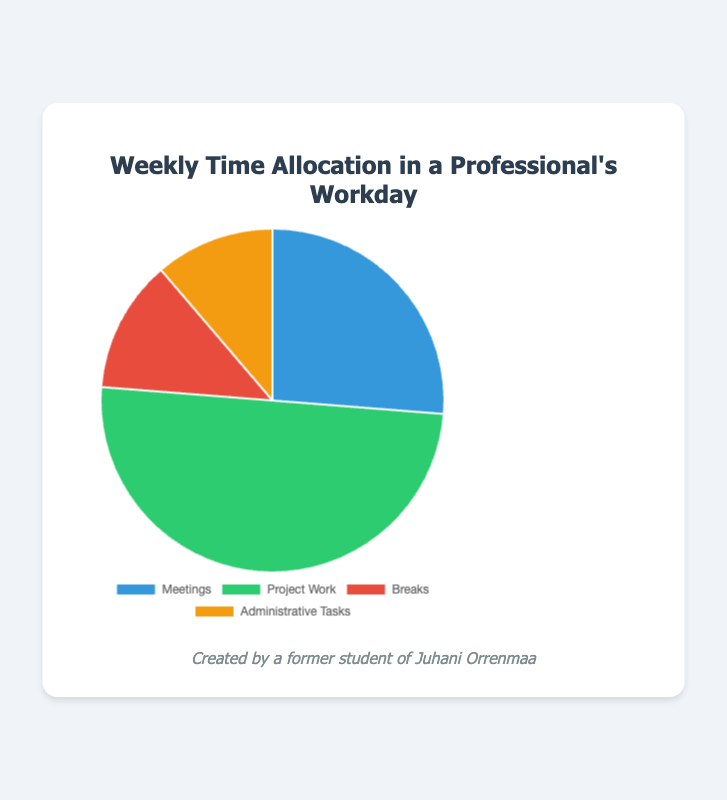What is the most time-consuming activity in a professional's workday? The figure shows the time allocation for various activities. Project Work takes up 20.0 hours, which is the highest among the activities listed.
Answer: Project Work What percentage of the total time is spent on Meetings? To find the percentage, sum up all the time allocations and then divide the time for Meetings by this total. The total time is 10.5 + 20.0 + 5.0 + 4.5 = 40.0 hours. The percentage for Meetings is (10.5 / 40.0) * 100 = 26.25%.
Answer: 26.25% How much more time is spent on Project Work compared to Breaks? Subtract the time spent on Breaks from the time spent on Project Work: 20.0 - 5.0 = 15.0 hours.
Answer: 15.0 hours What is the combined time spent on Breaks and Administrative Tasks? Sum the time for Breaks and Administrative Tasks: 5.0 + 4.5 = 9.5 hours.
Answer: 9.5 hours If the time for Meetings were increased by 50%, how much total time would that consume? Increase the time for Meetings by 50%: 10.5 * 1.5 = 15.75 hours.
Answer: 15.75 hours Which activity has the least amount of time allocated, and what is this amount? The figure shows the time allocation for each activity. Administrative Tasks have the least amount of time, which is 4.5 hours.
Answer: Administrative Tasks, 4.5 hours What fraction of the time is spent on Breaks compared to the total time? The total time is 40.0 hours, and the time spent on Breaks is 5.0 hours. The fraction is 5.0 / 40.0 = 1/8.
Answer: 1/8 What is the difference in time spent between Meetings and Administrative Tasks? Subtract the time for Administrative Tasks from the time for Meetings: 10.5 - 4.5 = 6.0 hours.
Answer: 6.0 hours 